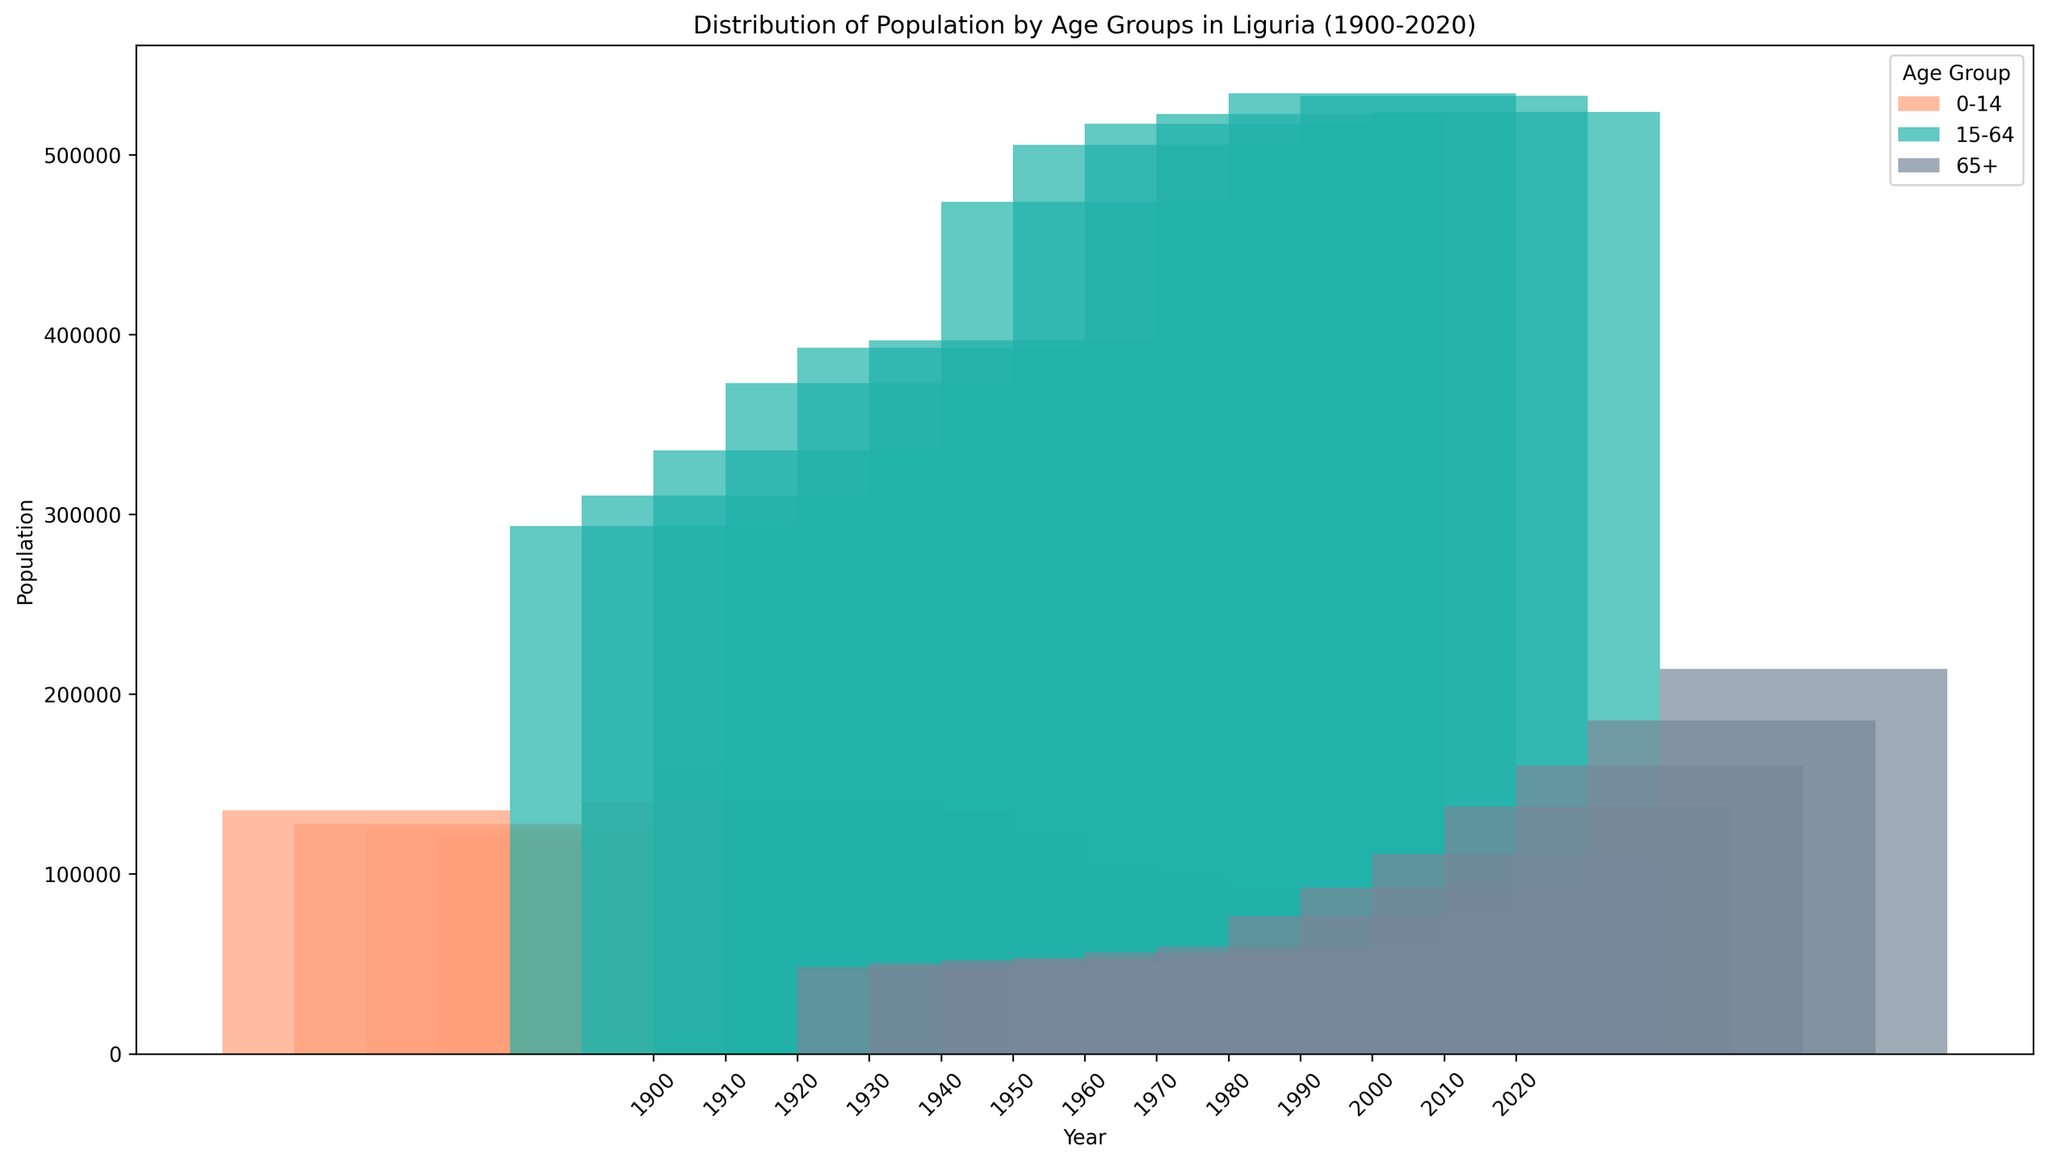Which age group had the largest population in 2020? Look at the bars corresponding to 2020 and compare their heights. The tallest bar represents the age group with the largest population.
Answer: 65+ Which year had the highest population for the 0-14 age group? Identify the years on the x-axis and locate the bars for the 0-14 age group. Then, find the year with the tallest bar for this age group.
Answer: 1960 By how much did the population of the 65+ age group increase from 1900 to 2020? Find the heights of the bars for the 65+ age group in 1900 and 2020. Subtract the 1900 value from the 2020 value. Population in 1900 (65+) = 48293, and in 2020 (65+) = 213984. (213984 - 48293)
Answer: 165691 In which decade did the population of the 15-64 age group peak? Find the decade where the 15-64 age group has the tallest bar. Notice whether there are increases or decreases each decade.
Answer: 2000s What is the difference in population between the 15-64 and the 0-14 age groups in 1980? Find the heights of the bars for the 15-64 and 0-14 age groups in 1980 and calculate their difference. Population in 1980 (15-64) = 517293, and in 1980 (0-14) = 135684. (517293 - 135684)
Answer: 381609 What visual color is used to represent the 15-64 age group? Look at the legend of the histogram to see which color corresponds to the 15-64 age group.
Answer: Green How did the population of the 0-14 age group change from 1950 to 2020? Compare the heights of the bars for the 0-14 age group in 1950 and 2020. Determine if the population increased or decreased and by how much. Population in 1950 (0-14) = 140295, and in 2020 (0-14) = 90573. (140295 - 90573)
Answer: Decreased by 49722 For which age group is the trend of population generally increasing over the years? Examine the bars for each age group across different years and observe the general trend. The 65+ age group shows a consistent increase in bar height over the years.
Answer: 65+ Which two decades saw a decline in the population of the 15-64 age group? Identify the bars for the 15-64 age group and look for periods where the heights of the bars decreased.
Answer: 2010s, 2020s 